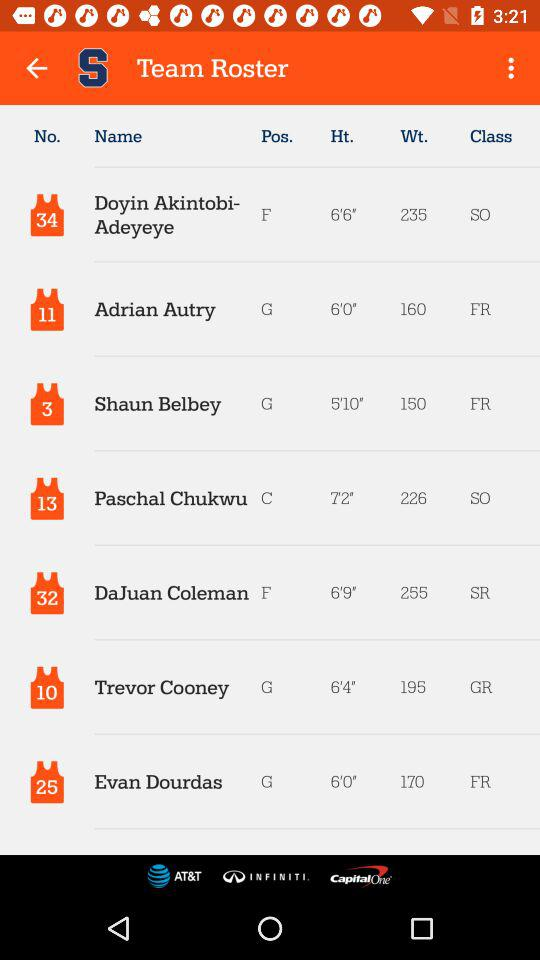What's the position of Trevor Cooney? The position of Trevor Cooney is "G". 